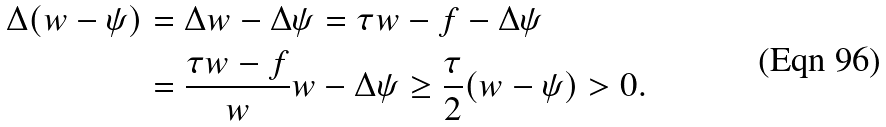<formula> <loc_0><loc_0><loc_500><loc_500>\Delta ( w - \psi ) & = \Delta w - \Delta \psi = \tau w - f - \Delta \psi \\ & = \frac { \tau w - f } { w } w - \Delta \psi \geq \frac { \tau } { 2 } ( w - \psi ) > 0 .</formula> 